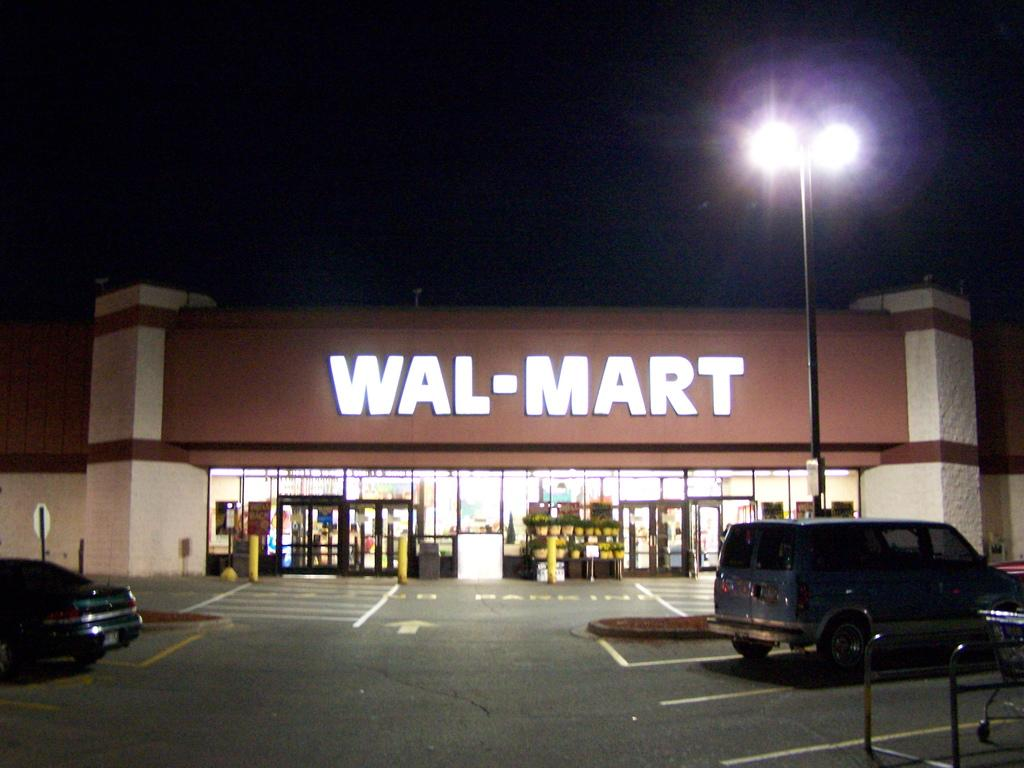<image>
Render a clear and concise summary of the photo. A van and a car are parked in a dark Wal-Mart parking lot. 